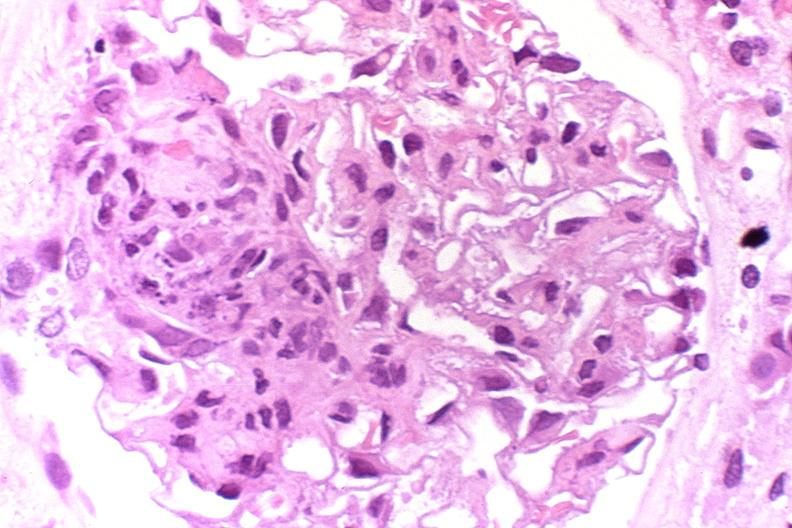s urinary present?
Answer the question using a single word or phrase. Yes 